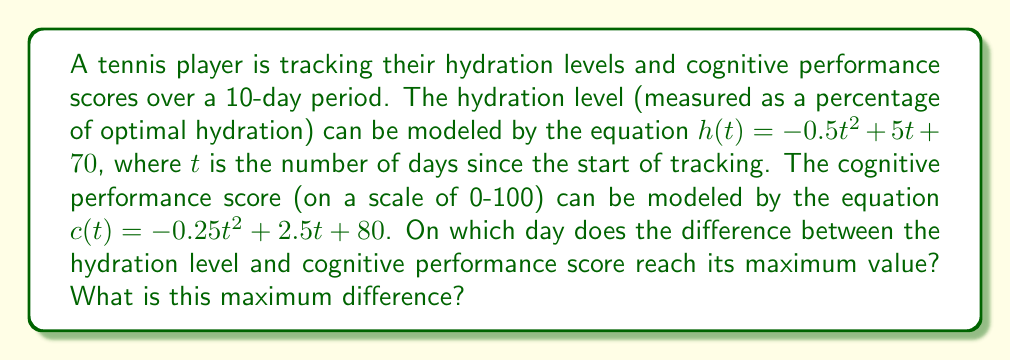Can you solve this math problem? To solve this problem, we need to follow these steps:

1) First, let's define the difference function $d(t)$ between hydration level and cognitive performance score:

   $d(t) = h(t) - c(t) = (-0.5t^2 + 5t + 70) - (-0.25t^2 + 2.5t + 80)$
   
   $d(t) = -0.25t^2 + 2.5t - 10$

2) To find the maximum value of this difference, we need to find where its derivative equals zero:

   $d'(t) = -0.5t + 2.5$

3) Set $d'(t) = 0$ and solve for $t$:

   $-0.5t + 2.5 = 0$
   $-0.5t = -2.5$
   $t = 5$

4) To confirm this is a maximum (not a minimum), we can check that the second derivative is negative:

   $d''(t) = -0.5$, which is indeed negative.

5) Therefore, the difference reaches its maximum on day 5.

6) To find the maximum difference, we plug $t=5$ into our difference function:

   $d(5) = -0.25(5)^2 + 2.5(5) - 10$
   $= -0.25(25) + 12.5 - 10$
   $= -6.25 + 12.5 - 10$
   $= -3.75$

Therefore, the maximum difference occurs on day 5, and the difference is -3.75.

Note: The negative value indicates that the cognitive performance score is actually 3.75 points higher than the hydration level at this point.
Answer: The difference between hydration level and cognitive performance score reaches its maximum on day 5, with a value of -3.75. 